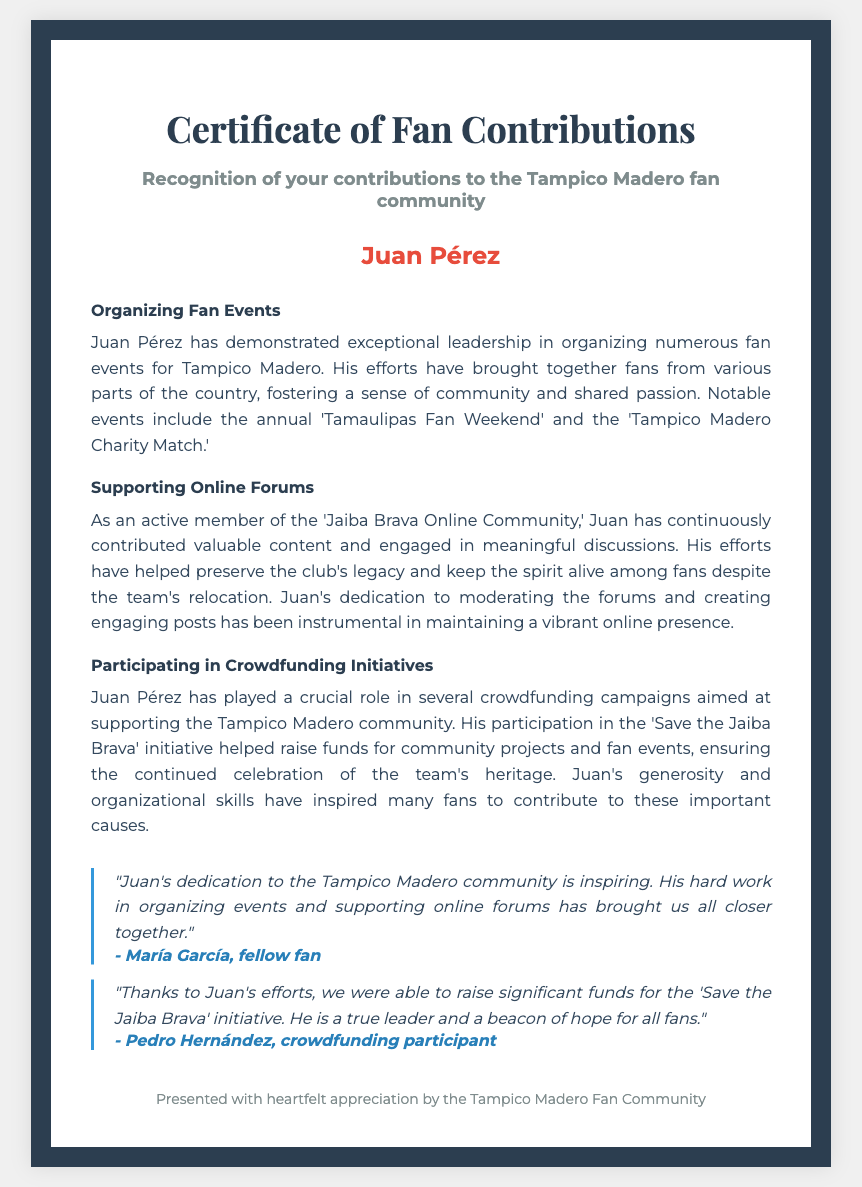What is the title of the document? The title is specified in the header section of the document, which is "Certificate of Fan Contributions."
Answer: Certificate of Fan Contributions Who is the recipient of the certificate? The recipient is mentioned prominently in the document under the recipient section, indicating the individual being recognized.
Answer: Juan Pérez What event is specifically mentioned in the certificate? The certificate lists notable events organized by the recipient, including the 'Tamaulipas Fan Weekend.'
Answer: Tamaulipas Fan Weekend What online community did Juan participate in? The document references the online community where Juan actively contributed, hinting at his involvement in discussions.
Answer: Jaiba Brava Online Community What initiative did Juan participate in to support the community? The certificate mentions a specific crowdfunding campaign Juan was part of aimed at supporting the Tampico Madero community.
Answer: Save the Jaiba Brava How did fellow fan María García describe Juan? The testimonial section includes comments from other fans, reflecting on Juan's contributions to the community.
Answer: Inspiring What type of events did Juan organize? The certificate highlights the role of Juan in planning events to foster community engagement among fans.
Answer: Fan events 